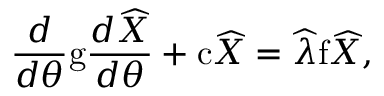<formula> <loc_0><loc_0><loc_500><loc_500>\frac { d } { d \theta } g \frac { d \widehat { X } } { d \theta } + c \widehat { X } = \widehat { \lambda } f \widehat { X } ,</formula> 